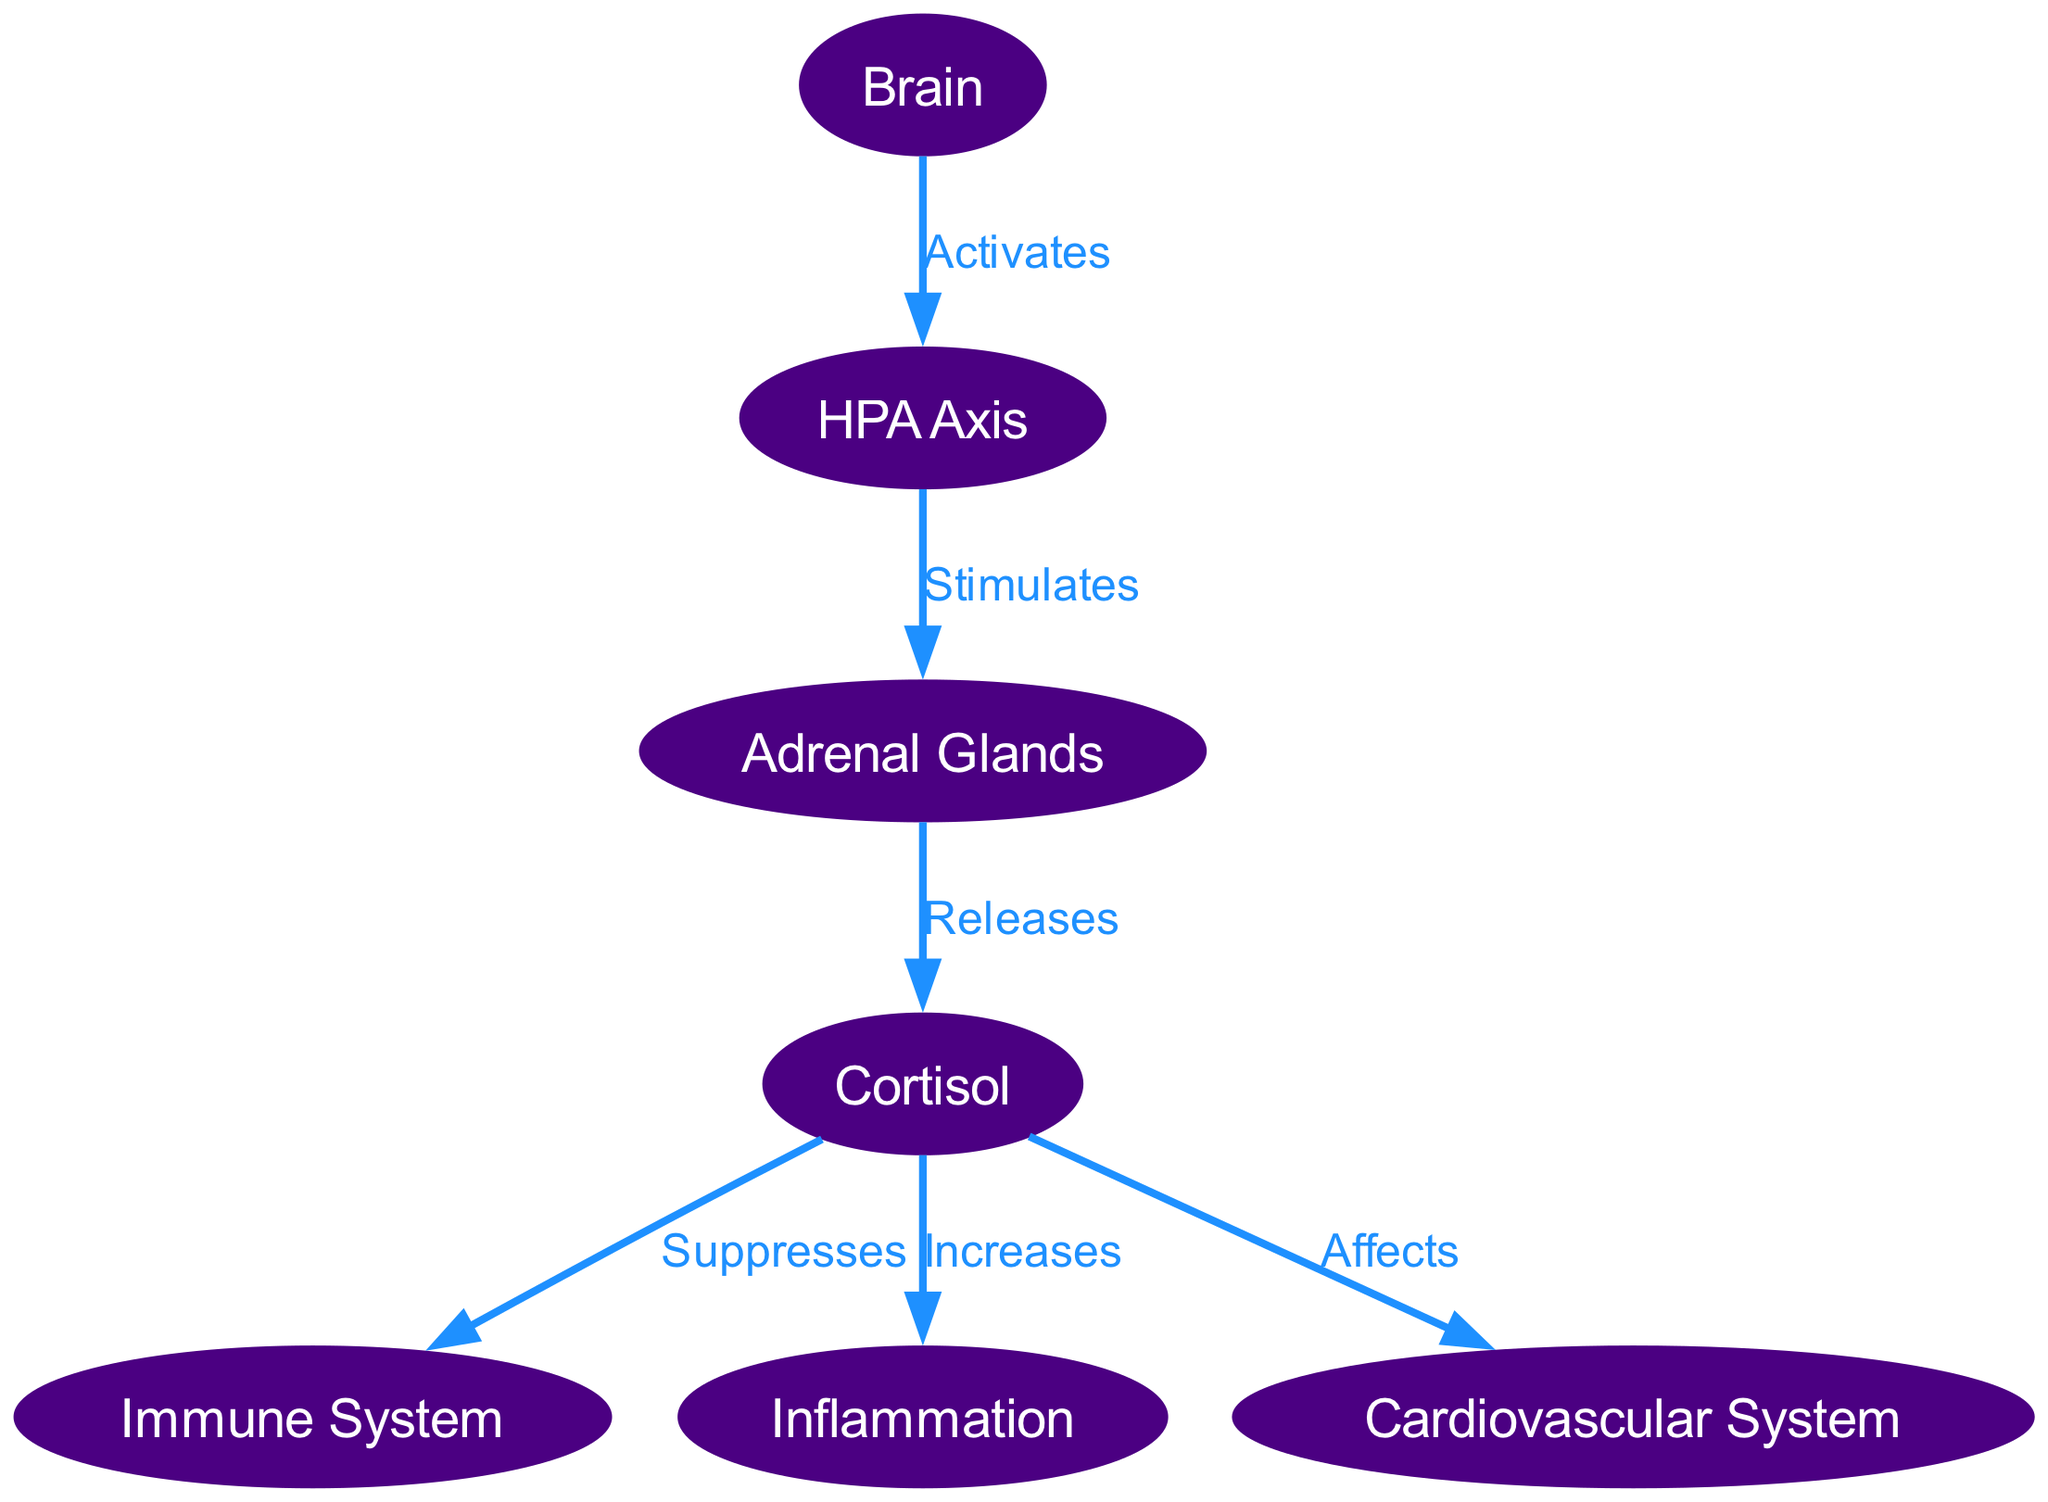What is the first node activated in the diagram? The diagram indicates that the process starts with the "Brain" node, which is the first entity activated by stress induced by health-related advertising.
Answer: Brain How many edges are present in the diagram? By counting the connections (relationships) between nodes in the diagram, there are 6 distinct edges that illustrate the interactions between the biological components.
Answer: 6 What does the HPA Axis stimulate? According to the diagram, the HPA Axis has a connection that indicates it stimulates the "Adrenal Glands".
Answer: Adrenal Glands What is the relationship between cortisol and the immune system? The diagram explicitly states that cortisol "Suppresses" the immune system, illustrating a direct effect of cortisol on immune function.
Answer: Suppresses Which system does cortisol affect according to the diagram? The edges in the diagram indicate that cortisol affects the "Cardiovascular System", demonstrating its influence on cardiovascular health.
Answer: Cardiovascular System Which node releases cortisol? The diagram shows that the "Adrenal Glands" are responsible for releasing cortisol when stimulated by the HPA Axis, clearly indicating the flow of effects.
Answer: Adrenal Glands What effect does cortisol have on inflammation? The diagram indicates that cortisol "Increases" inflammation, depicting its role in physiological responses.
Answer: Increases Explain the flow starting from the brain to the cardiovascular system. The process begins at the "Brain," which activates the "HPA Axis." The HPA Axis subsequently stimulates the "Adrenal Glands," leading to the release of "Cortisol." Finally, cortisol affects the "Cardiovascular System," demonstrating a clear flow from one component to the next.
Answer: Brain → HPA Axis → Adrenal Glands → Cortisol → Cardiovascular System What node represents the immune system in the diagram? The diagram includes a dedicated node labeled "Immune System," which represents the body's defense mechanisms against pathogens and stressors.
Answer: Immune System 